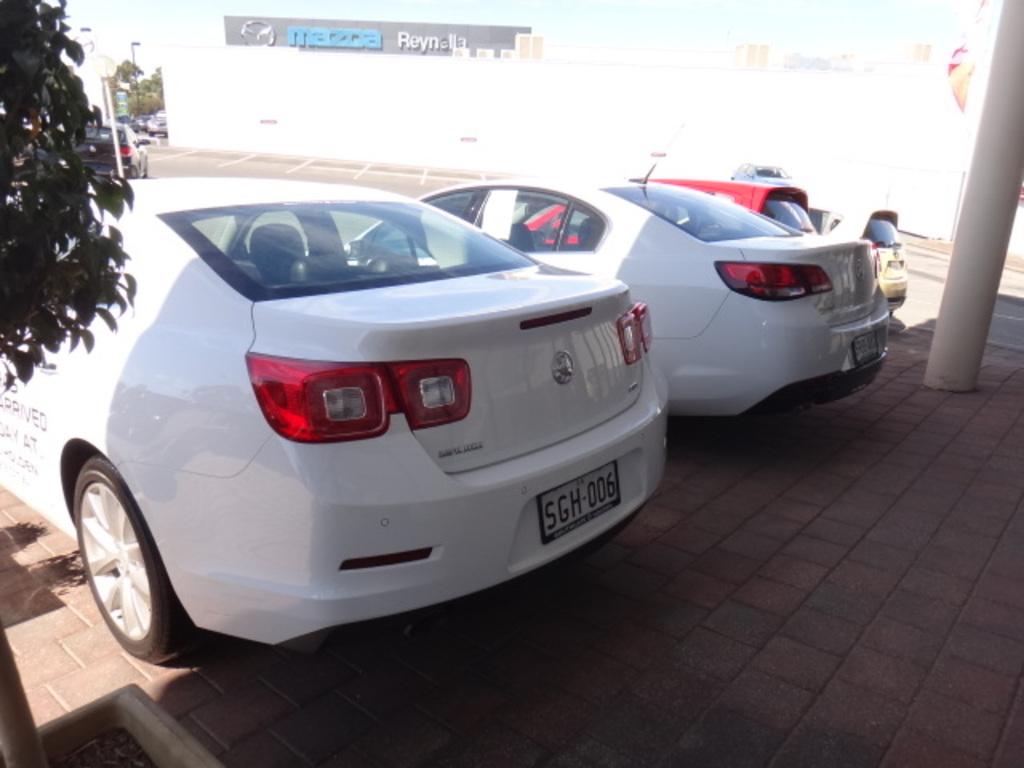What car make is on the sign in the background?
Ensure brevity in your answer.  Mazda. 